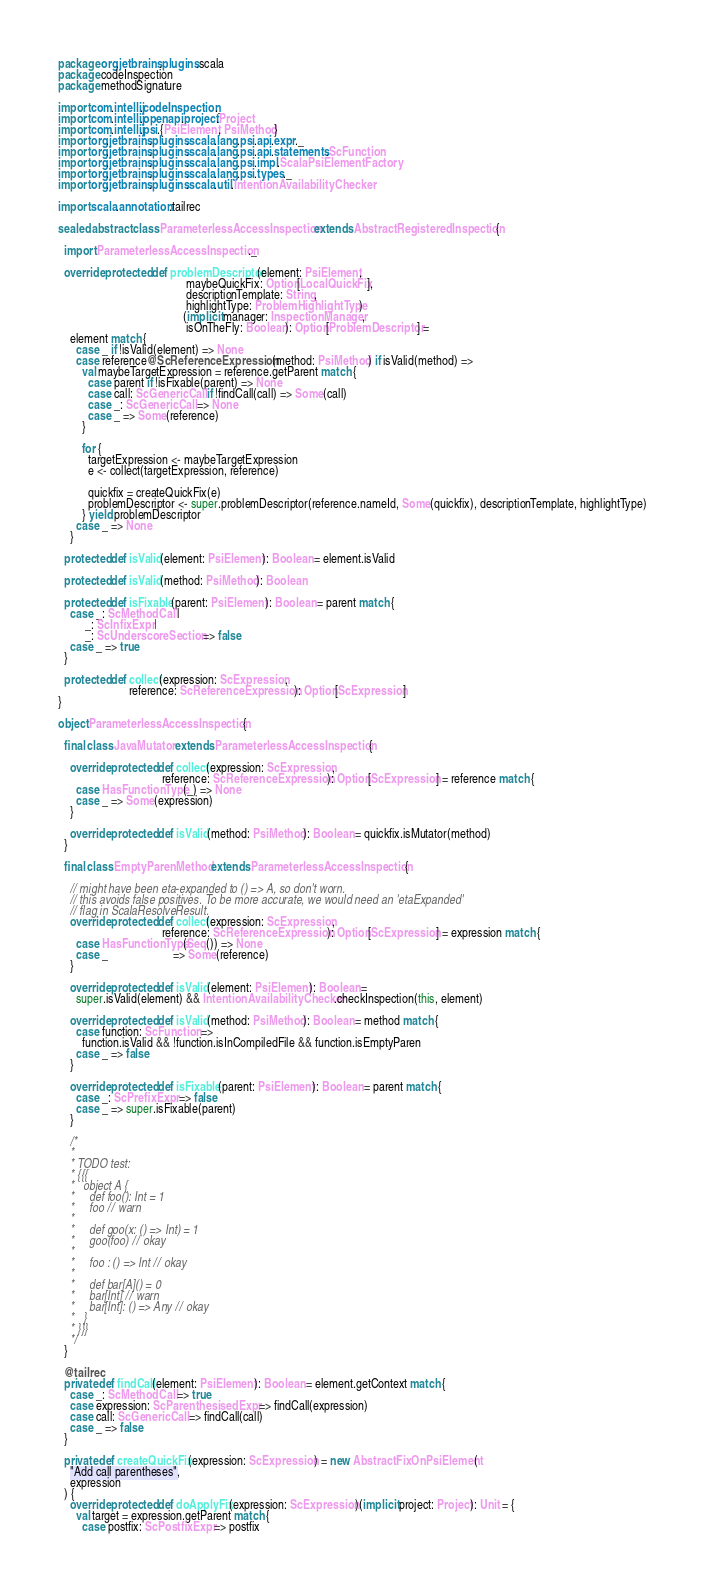<code> <loc_0><loc_0><loc_500><loc_500><_Scala_>package org.jetbrains.plugins.scala
package codeInspection
package methodSignature

import com.intellij.codeInspection._
import com.intellij.openapi.project.Project
import com.intellij.psi.{PsiElement, PsiMethod}
import org.jetbrains.plugins.scala.lang.psi.api.expr._
import org.jetbrains.plugins.scala.lang.psi.api.statements.ScFunction
import org.jetbrains.plugins.scala.lang.psi.impl.ScalaPsiElementFactory
import org.jetbrains.plugins.scala.lang.psi.types._
import org.jetbrains.plugins.scala.util.IntentionAvailabilityChecker

import scala.annotation.tailrec

sealed abstract class ParameterlessAccessInspection extends AbstractRegisteredInspection {

  import ParameterlessAccessInspection._

  override protected def problemDescriptor(element: PsiElement,
                                           maybeQuickFix: Option[LocalQuickFix],
                                           descriptionTemplate: String,
                                           highlightType: ProblemHighlightType)
                                          (implicit manager: InspectionManager,
                                           isOnTheFly: Boolean): Option[ProblemDescriptor] =
    element match {
      case _ if !isValid(element) => None
      case reference@ScReferenceExpression(method: PsiMethod) if isValid(method) =>
        val maybeTargetExpression = reference.getParent match {
          case parent if !isFixable(parent) => None
          case call: ScGenericCall if !findCall(call) => Some(call)
          case _: ScGenericCall => None
          case _ => Some(reference)
        }

        for {
          targetExpression <- maybeTargetExpression
          e <- collect(targetExpression, reference)

          quickfix = createQuickFix(e)
          problemDescriptor <- super.problemDescriptor(reference.nameId, Some(quickfix), descriptionTemplate, highlightType)
        } yield problemDescriptor
      case _ => None
    }

  protected def isValid(element: PsiElement): Boolean = element.isValid

  protected def isValid(method: PsiMethod): Boolean

  protected def isFixable(parent: PsiElement): Boolean = parent match {
    case _: ScMethodCall |
         _: ScInfixExpr |
         _: ScUnderscoreSection => false
    case _ => true
  }

  protected def collect(expression: ScExpression,
                        reference: ScReferenceExpression): Option[ScExpression]
}

object ParameterlessAccessInspection {

  final class JavaMutator extends ParameterlessAccessInspection {

    override protected def collect(expression: ScExpression,
                                   reference: ScReferenceExpression): Option[ScExpression] = reference match {
      case HasFunctionType(_) => None
      case _ => Some(expression)
    }

    override protected def isValid(method: PsiMethod): Boolean = quickfix.isMutator(method)
  }

  final class EmptyParenMethod extends ParameterlessAccessInspection {

    // might have been eta-expanded to () => A, so don't worn.
    // this avoids false positives. To be more accurate, we would need an 'etaExpanded'
    // flag in ScalaResolveResult.
    override protected def collect(expression: ScExpression,
                                   reference: ScReferenceExpression): Option[ScExpression] = expression match {
      case HasFunctionType(Seq()) => None
      case _                      => Some(reference)
    }

    override protected def isValid(element: PsiElement): Boolean =
      super.isValid(element) && IntentionAvailabilityChecker.checkInspection(this, element)

    override protected def isValid(method: PsiMethod): Boolean = method match {
      case function: ScFunction =>
        function.isValid && !function.isInCompiledFile && function.isEmptyParen
      case _ => false
    }

    override protected def isFixable(parent: PsiElement): Boolean = parent match {
      case _: ScPrefixExpr => false
      case _ => super.isFixable(parent)
    }

    /*
    *
    * TODO test:
    * {{{
    *   object A {
    *     def foo(): Int = 1
    *     foo // warn
    *
    *     def goo(x: () => Int) = 1
    *     goo(foo) // okay
    *
    *     foo : () => Int // okay
    *
    *     def bar[A]() = 0
    *     bar[Int] // warn
    *     bar[Int]: () => Any // okay
    *   }
    * }}}
    */
  }

  @tailrec
  private def findCall(element: PsiElement): Boolean = element.getContext match {
    case _: ScMethodCall => true
    case expression: ScParenthesisedExpr => findCall(expression)
    case call: ScGenericCall => findCall(call)
    case _ => false
  }

  private def createQuickFix(expression: ScExpression) = new AbstractFixOnPsiElement(
    "Add call parentheses",
    expression
  ) {
    override protected def doApplyFix(expression: ScExpression)(implicit project: Project): Unit = {
      val target = expression.getParent match {
        case postfix: ScPostfixExpr => postfix</code> 